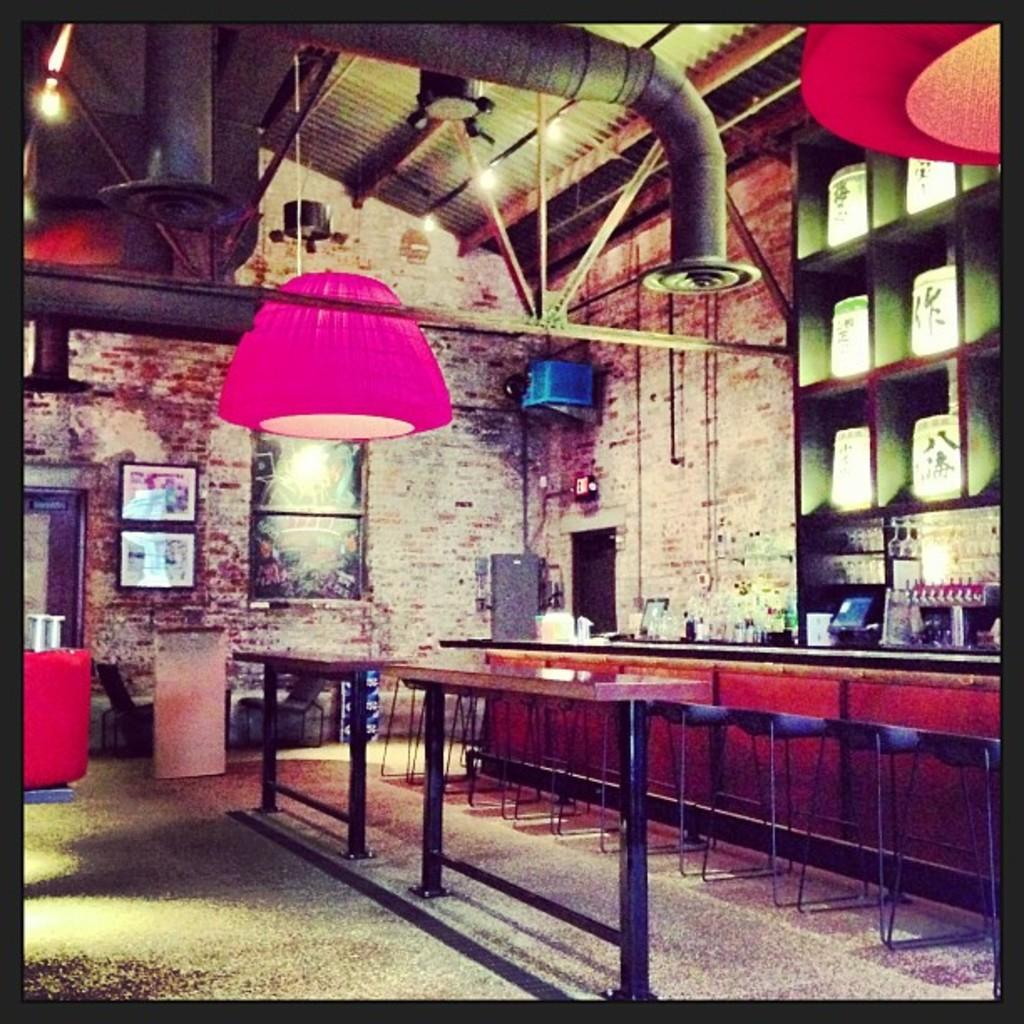What type of space is shown in the image? The image depicts a room. What type of furniture is located on the right side of the room? There are chairs on the right side of the room. What is in the middle of the room? There are dining tables in the middle of the room. What angle does the rainstorm hit the room in the image? There is no rainstorm present in the image, so it is not possible to determine the angle at which it might hit the room. 